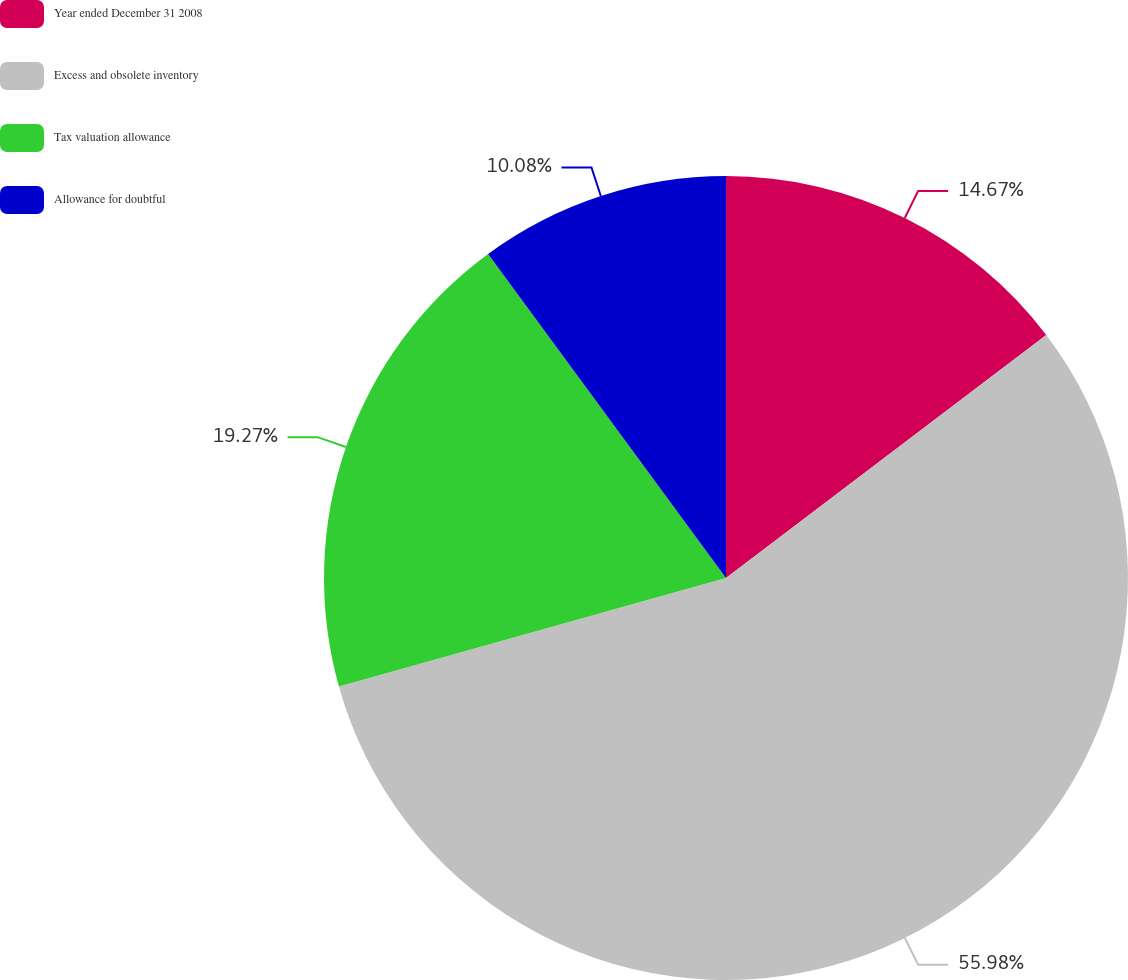Convert chart to OTSL. <chart><loc_0><loc_0><loc_500><loc_500><pie_chart><fcel>Year ended December 31 2008<fcel>Excess and obsolete inventory<fcel>Tax valuation allowance<fcel>Allowance for doubtful<nl><fcel>14.67%<fcel>55.98%<fcel>19.27%<fcel>10.08%<nl></chart> 